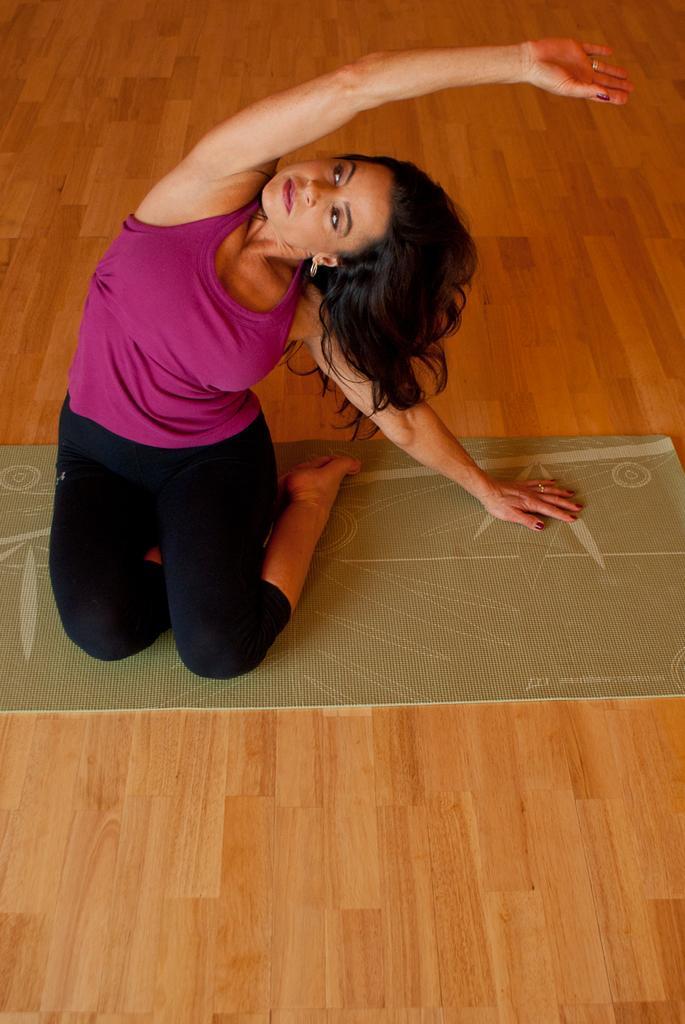How would you summarize this image in a sentence or two? The woman in purple T-shirt is practicing the yoga on the green color mat. At the bottom of the picture, we see a wooden floor. 